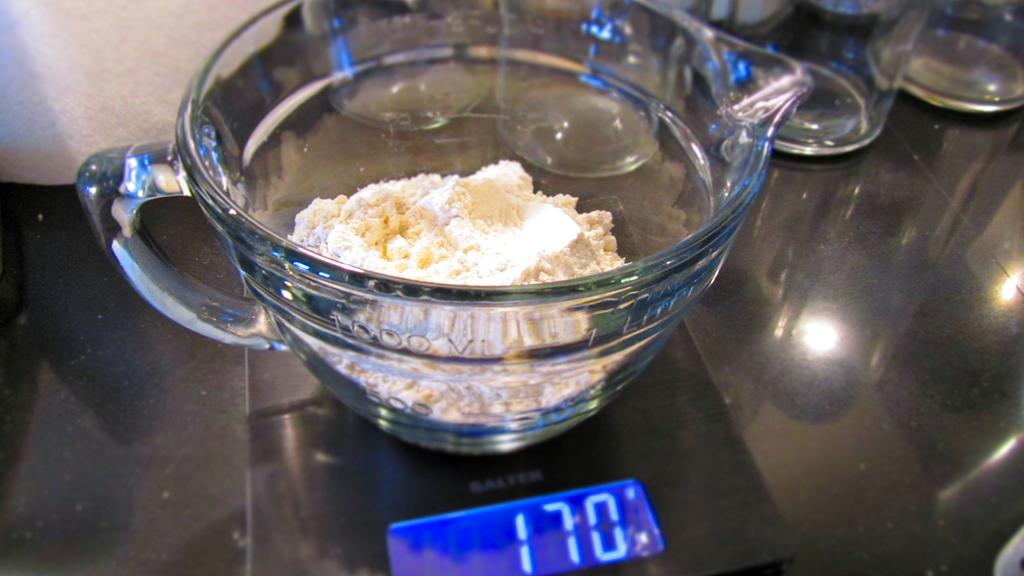What is located in the foreground of the image? There is a glass cup in the foreground of the image. What is inside the glass cup? The glass cup contains powder. What can be seen in front of the glass cup? There appears to be a gadget in front of the glass cup. What is visible in the background of the image? There are glasses visible in the background of the image. How does the pain manifest itself in the image? There is no mention of pain in the image, as it features a glass cup, powder, a gadget, and glasses. What type of can is visible in the image? There is no can present in the image. 